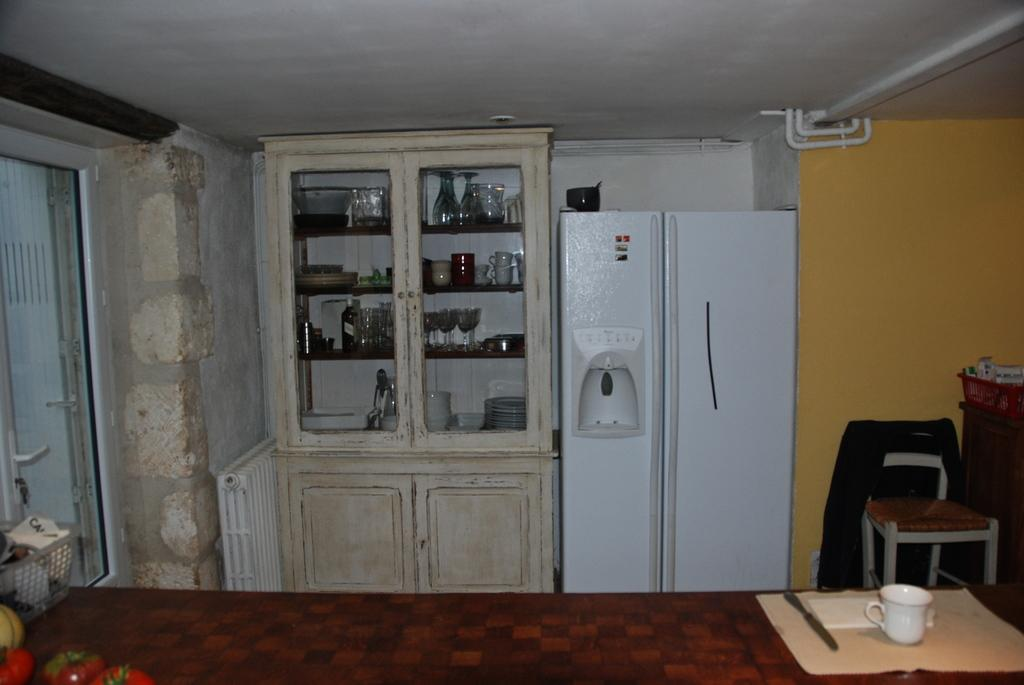What objects can be seen in the image? There are glasses, a refrigerator, a cup, and a knife on a plate in the image. Where is the refrigerator located in relation to the glasses? The refrigerator is next to the glasses. What is on the plate in the image? There is a cup and a knife on the plate in the image. What can be seen in the background of the image? There is a chair and a wall in the background of the image. What type of stamp can be seen on the refrigerator in the image? There is no stamp present on the refrigerator in the image. Is there an alley visible in the background of the image? There is no alley present in the image; only a chair and a wall are visible in the background. 